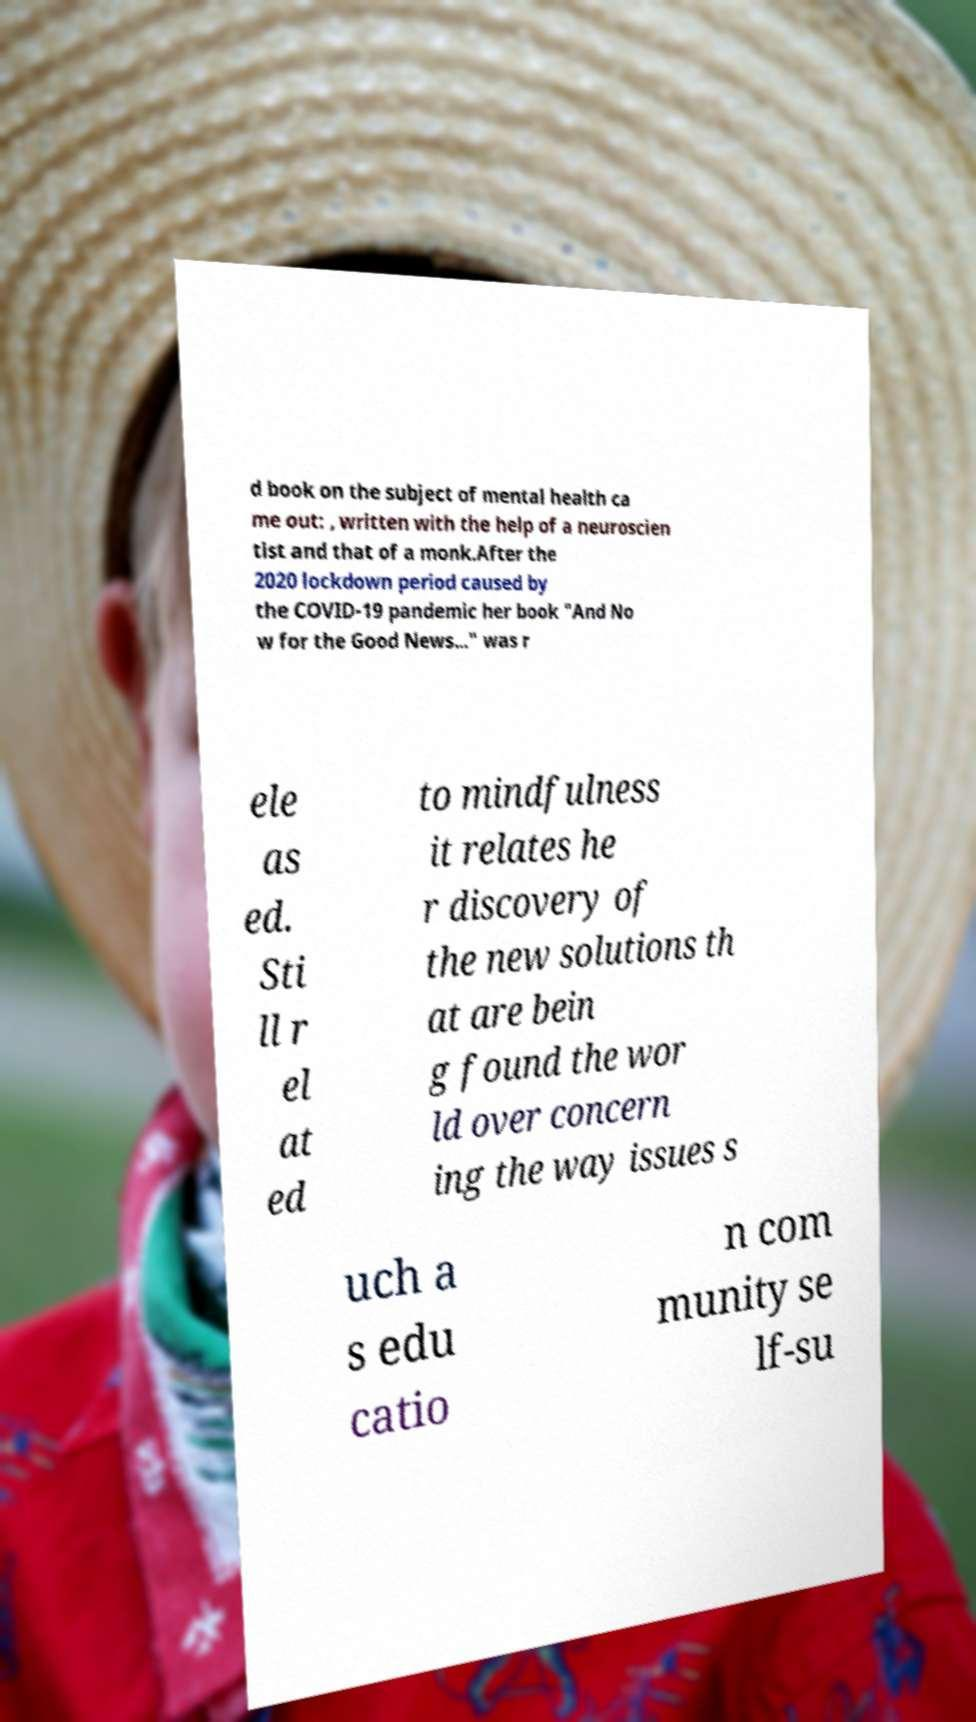Can you accurately transcribe the text from the provided image for me? d book on the subject of mental health ca me out: , written with the help of a neuroscien tist and that of a monk.After the 2020 lockdown period caused by the COVID-19 pandemic her book "And No w for the Good News..." was r ele as ed. Sti ll r el at ed to mindfulness it relates he r discovery of the new solutions th at are bein g found the wor ld over concern ing the way issues s uch a s edu catio n com munity se lf-su 